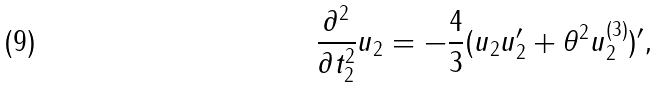<formula> <loc_0><loc_0><loc_500><loc_500>\frac { \partial ^ { 2 } } { \partial t _ { 2 } ^ { 2 } } u _ { 2 } = - \frac { 4 } { 3 } ( u _ { 2 } u _ { 2 } ^ { \prime } + { \theta } ^ { 2 } u _ { 2 } ^ { ( 3 ) } ) ^ { \prime } ,</formula> 